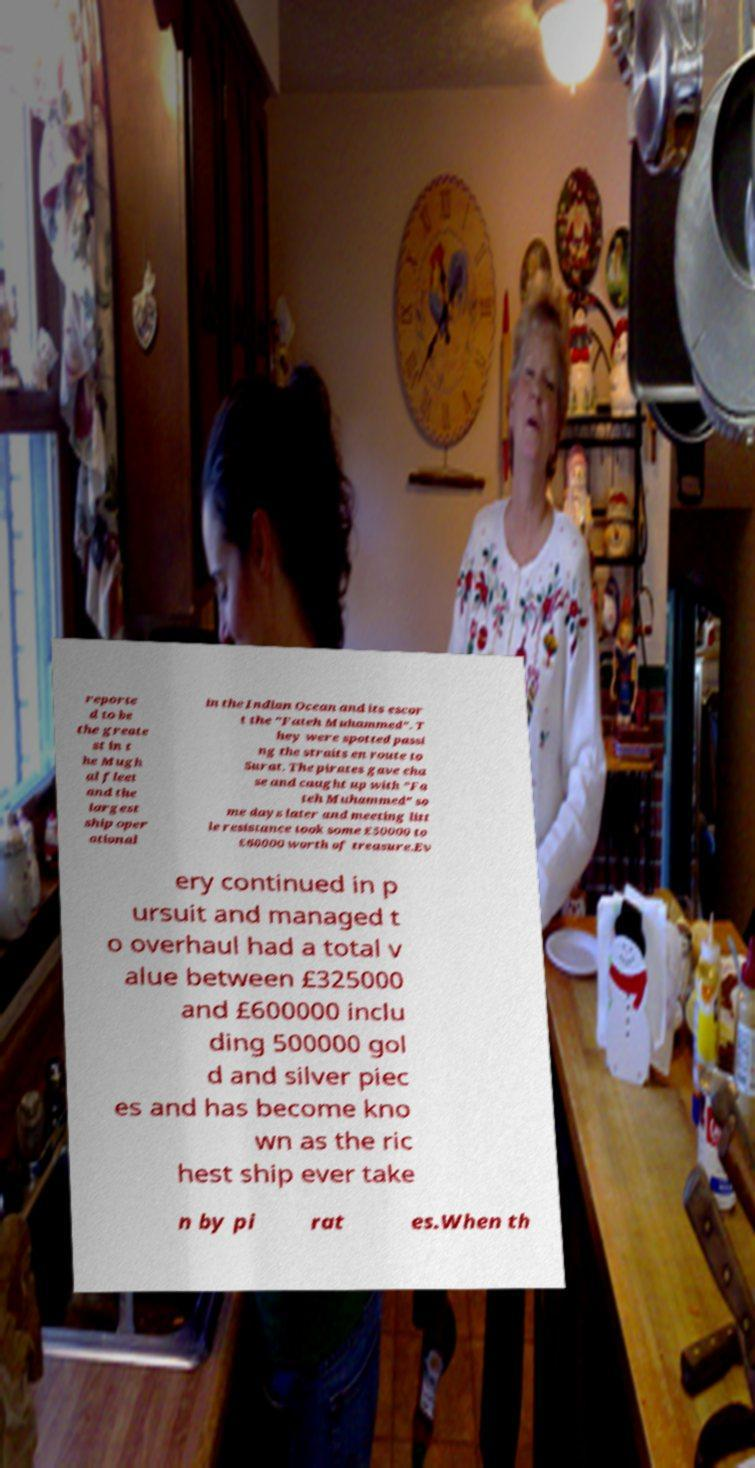Could you assist in decoding the text presented in this image and type it out clearly? reporte d to be the greate st in t he Mugh al fleet and the largest ship oper ational in the Indian Ocean and its escor t the "Fateh Muhammed". T hey were spotted passi ng the straits en route to Surat. The pirates gave cha se and caught up with "Fa teh Muhammed" so me days later and meeting litt le resistance took some £50000 to £60000 worth of treasure.Ev ery continued in p ursuit and managed t o overhaul had a total v alue between £325000 and £600000 inclu ding 500000 gol d and silver piec es and has become kno wn as the ric hest ship ever take n by pi rat es.When th 